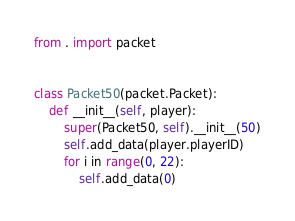Convert code to text. <code><loc_0><loc_0><loc_500><loc_500><_Python_>from . import packet


class Packet50(packet.Packet):
    def __init__(self, player):
        super(Packet50, self).__init__(50)
        self.add_data(player.playerID)
        for i in range(0, 22):
            self.add_data(0)
</code> 